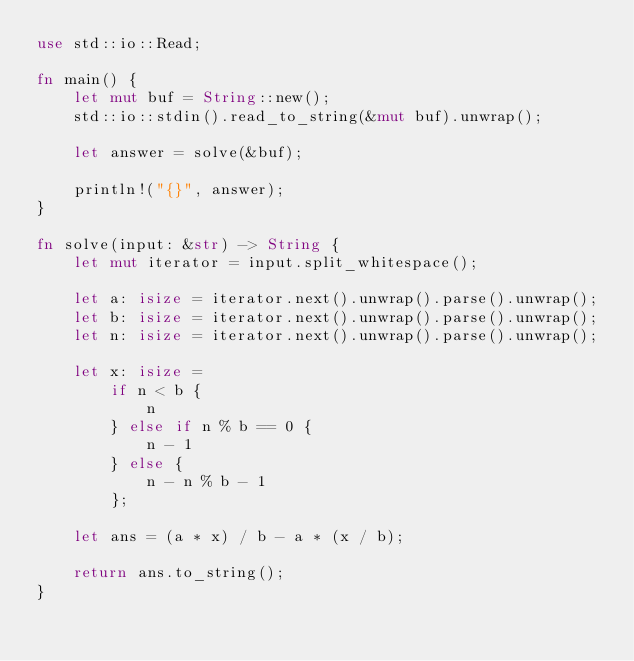<code> <loc_0><loc_0><loc_500><loc_500><_Rust_>use std::io::Read;

fn main() {
    let mut buf = String::new();
    std::io::stdin().read_to_string(&mut buf).unwrap();

    let answer = solve(&buf);

    println!("{}", answer);
}

fn solve(input: &str) -> String {
    let mut iterator = input.split_whitespace();

    let a: isize = iterator.next().unwrap().parse().unwrap();
    let b: isize = iterator.next().unwrap().parse().unwrap();
    let n: isize = iterator.next().unwrap().parse().unwrap();

    let x: isize =
        if n < b {
            n
        } else if n % b == 0 {
            n - 1
        } else {
            n - n % b - 1
        };

    let ans = (a * x) / b - a * (x / b);

    return ans.to_string();
}
</code> 